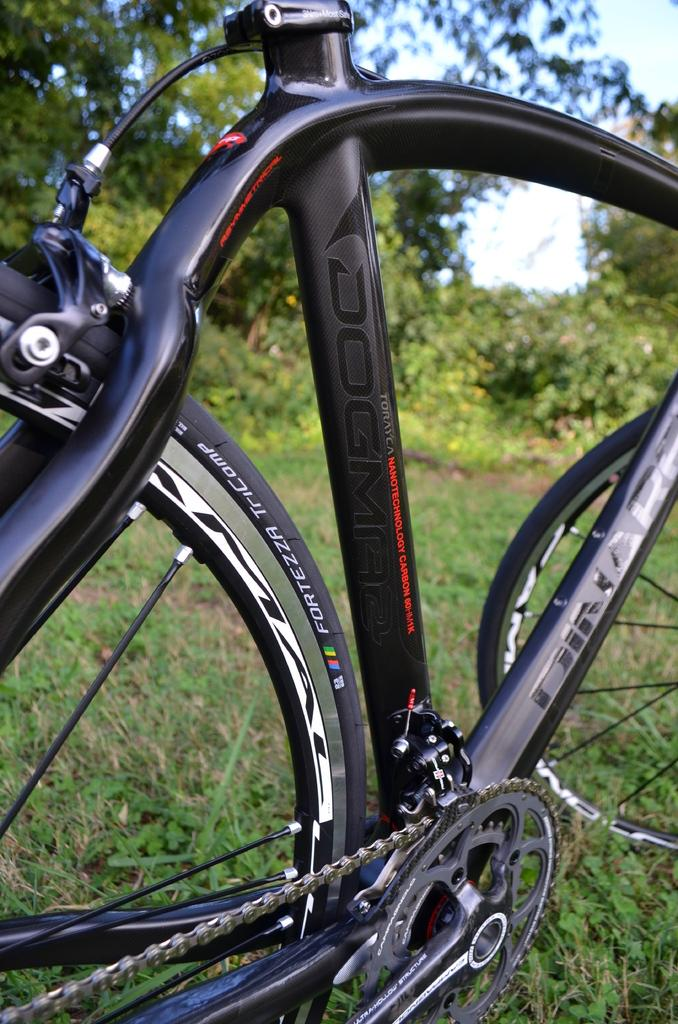What is the main object in the image? There is a bicycle in the image. What type of terrain is visible in the image? There is grass visible in the image. Are there any natural elements present in the image? Yes, there are trees in the image. What type of leather is used to make the bicycle's pocket in the image? There is no leather or pocket present on the bicycle in the image. 